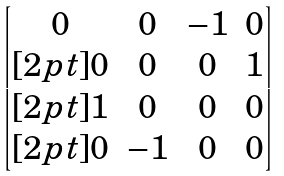Convert formula to latex. <formula><loc_0><loc_0><loc_500><loc_500>\begin{bmatrix} 0 & 0 & - 1 & 0 \\ [ 2 p t ] 0 & 0 & 0 & 1 \\ [ 2 p t ] 1 & 0 & 0 & 0 \\ [ 2 p t ] 0 & - 1 & 0 & 0 \end{bmatrix}</formula> 